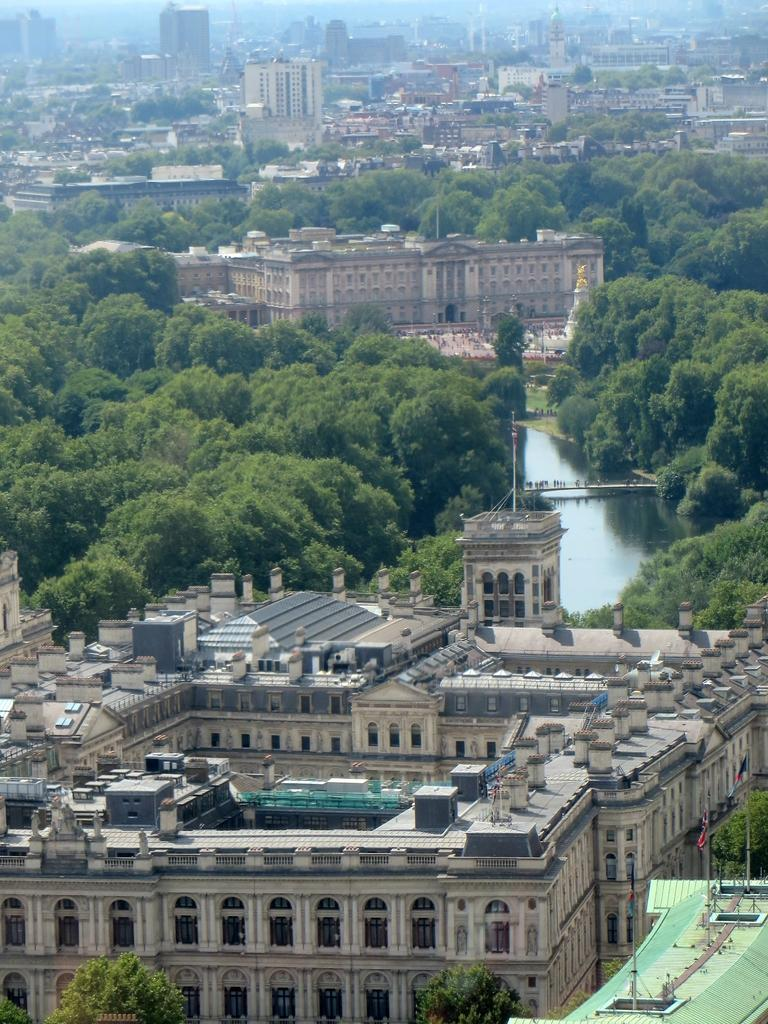What type of structures can be seen in the image? There are buildings in the image. What natural elements are present in the image? There are trees in the image. What man-made feature connects two areas in the image? There is a bridge in the image. Are there any people visible in the image? Yes, there are people in the image. What type of decorative or symbolic objects can be seen in the image? There are flags in the image. What vertical structures are present in the image? There are poles in the image. What type of architectural element is present in the image? There is a roof in the image. What is visible at the top of the image? The sky is visible at the top of the image. Can you tell me how many quills are being used by the people in the image? There is no mention of quills in the image, so it is impossible to determine how many are being used. What type of lock can be seen securing the bridge in the image? There is no lock visible on the bridge in the image. 